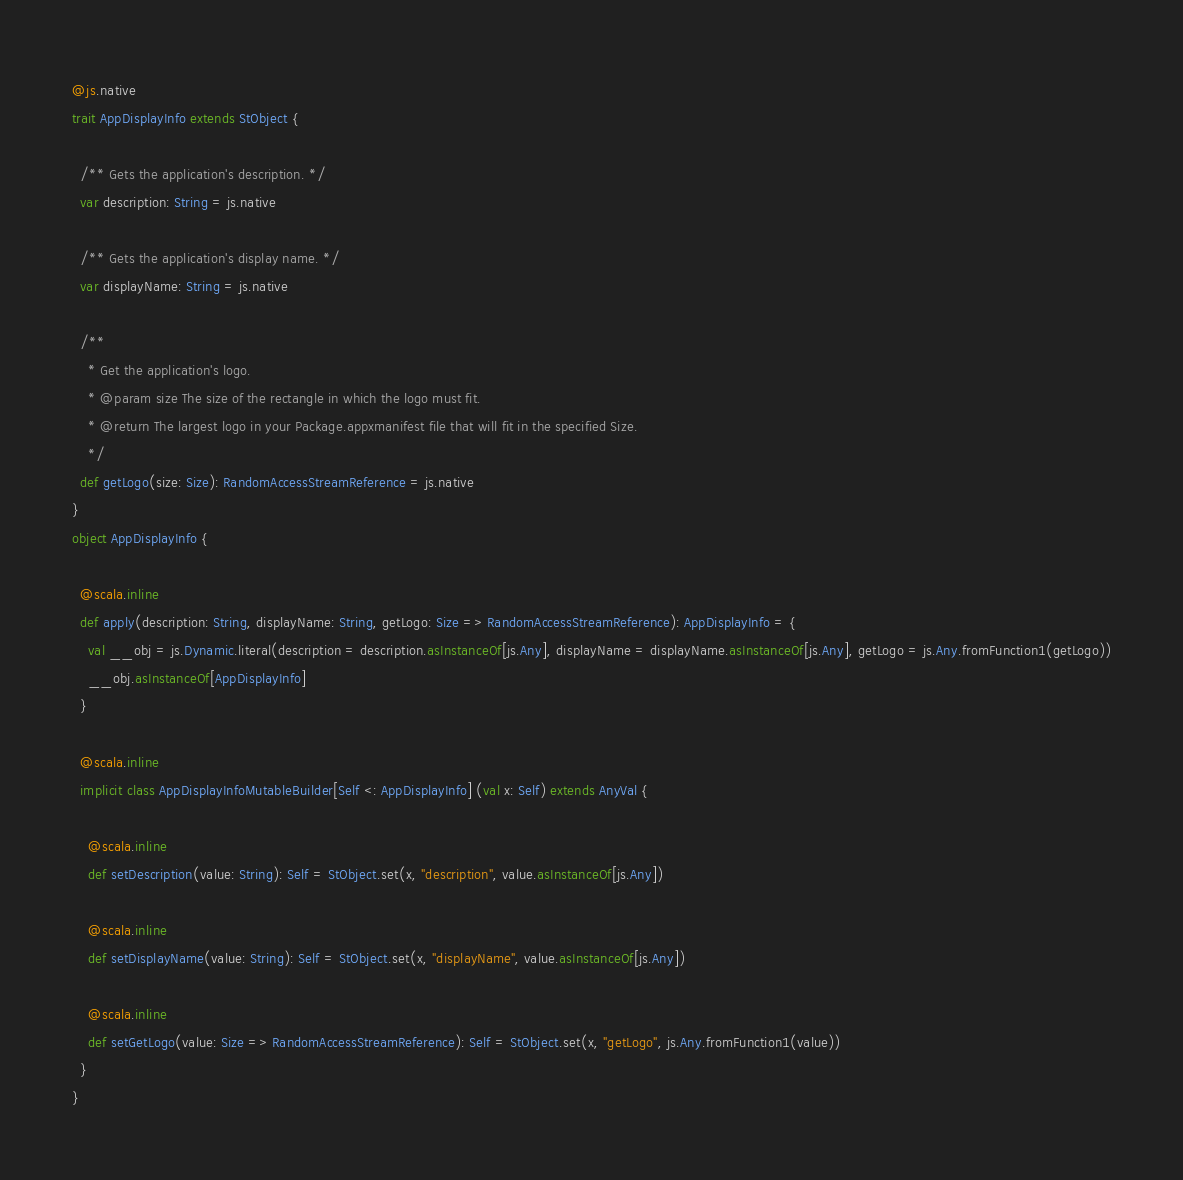<code> <loc_0><loc_0><loc_500><loc_500><_Scala_>@js.native
trait AppDisplayInfo extends StObject {
  
  /** Gets the application's description. */
  var description: String = js.native
  
  /** Gets the application's display name. */
  var displayName: String = js.native
  
  /**
    * Get the application's logo.
    * @param size The size of the rectangle in which the logo must fit.
    * @return The largest logo in your Package.appxmanifest file that will fit in the specified Size.
    */
  def getLogo(size: Size): RandomAccessStreamReference = js.native
}
object AppDisplayInfo {
  
  @scala.inline
  def apply(description: String, displayName: String, getLogo: Size => RandomAccessStreamReference): AppDisplayInfo = {
    val __obj = js.Dynamic.literal(description = description.asInstanceOf[js.Any], displayName = displayName.asInstanceOf[js.Any], getLogo = js.Any.fromFunction1(getLogo))
    __obj.asInstanceOf[AppDisplayInfo]
  }
  
  @scala.inline
  implicit class AppDisplayInfoMutableBuilder[Self <: AppDisplayInfo] (val x: Self) extends AnyVal {
    
    @scala.inline
    def setDescription(value: String): Self = StObject.set(x, "description", value.asInstanceOf[js.Any])
    
    @scala.inline
    def setDisplayName(value: String): Self = StObject.set(x, "displayName", value.asInstanceOf[js.Any])
    
    @scala.inline
    def setGetLogo(value: Size => RandomAccessStreamReference): Self = StObject.set(x, "getLogo", js.Any.fromFunction1(value))
  }
}
</code> 